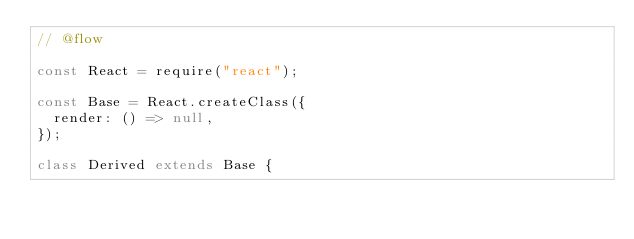<code> <loc_0><loc_0><loc_500><loc_500><_JavaScript_>// @flow

const React = require("react");

const Base = React.createClass({
  render: () => null,
});

class Derived extends Base {</code> 